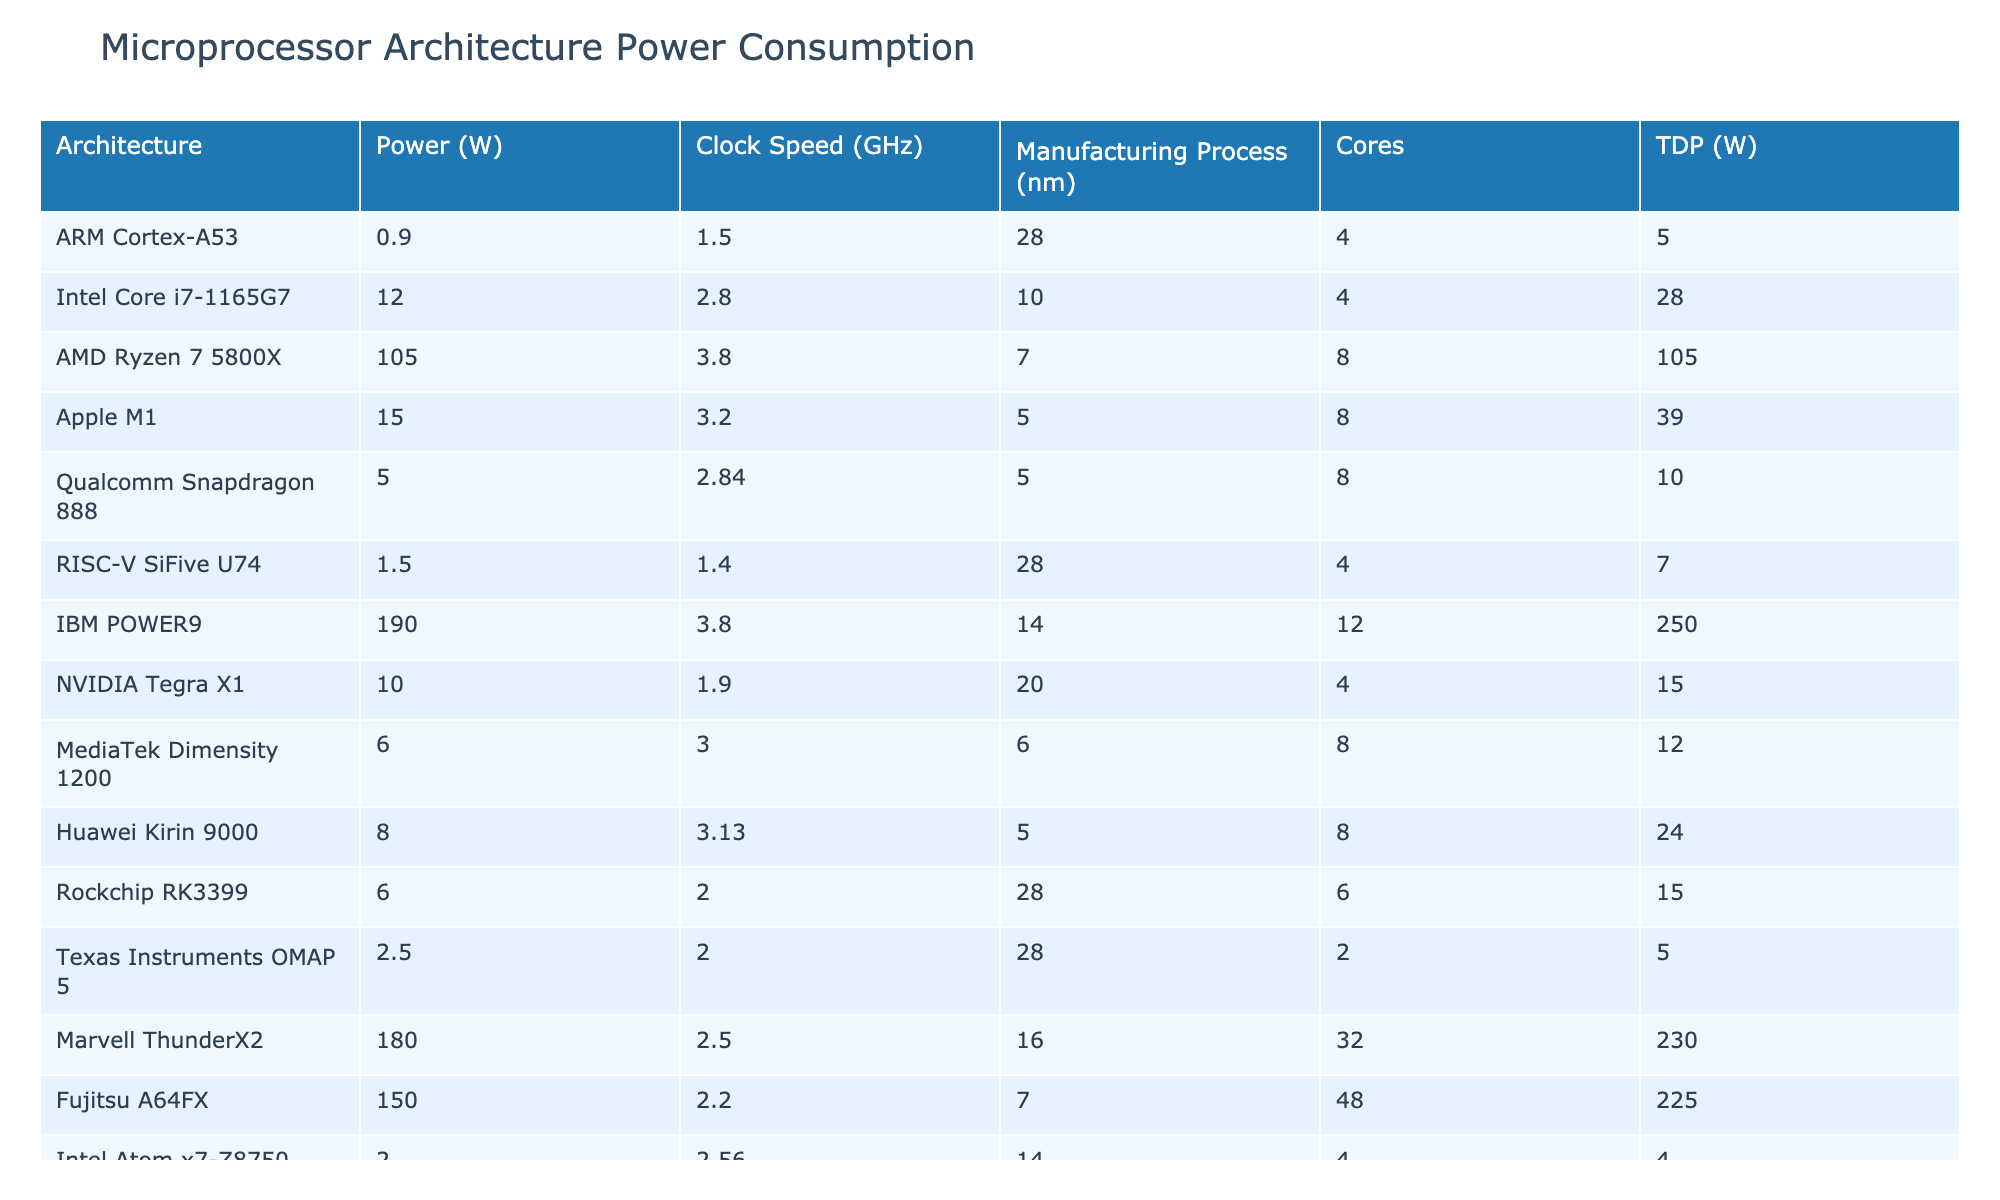What is the power consumption of the Intel Core i7-1165G7? From the table, we can locate the row for the Intel Core i7-1165G7 and read the corresponding power consumption value directly, which is 12 watts.
Answer: 12 W Which microprocessor architecture has the highest power consumption? By examining the table, the architecture with the highest power consumption is IBM POWER9, with a power consumption of 190 watts.
Answer: IBM POWER9 What is the total power consumption of all microprocessors listed? To find the total power consumption, we sum all the values in the 'Power (W)' column: 0.9 + 12 + 105 + 15 + 5 + 1.5 + 190 + 10 + 6 + 8 + 6 + 2.5 + 180 + 150 + 2 = 573.9 watts.
Answer: 573.9 W What is the average power consumption of the microprocessors using a 10 nm manufacturing process? From the table, there is only one entry with a 10 nm manufacturing process, which is the Intel Core i7-1165G7 with a power consumption of 12 watts. Hence, the average is simply 12 watts.
Answer: 12 W Is there a microprocessor architecture with a power consumption less than 5 watts? Looking at the table, the ARM Cortex-A53 is the only architecture with a power consumption less than 5 watts, consuming 0.9 watts. This confirms that yes, there is a microprocessor architecture under 5 watts.
Answer: Yes Which microprocessor has the most cores among those listed? By checking the 'Cores' column, IBM POWER9 has the highest number of cores, which is 12 cores.
Answer: IBM POWER9 What is the difference in power consumption between the highest and lowest power consuming microprocessors? The highest power consuming microprocessor is IBM POWER9 at 190 watts and the lowest is ARM Cortex-A53 at 0.9 watts. The difference is 190 - 0.9 = 189.1 watts.
Answer: 189.1 W List the architectures that consume more than 100 watts of power. By examining the 'Power (W)' column, the architectures that exceed 100 watts are AMD Ryzen 7 5800X (105 W), IBM POWER9 (190 W), Marvell ThunderX2 (180 W), and Fujitsu A64FX (150 W).
Answer: AMD Ryzen 7 5800X, IBM POWER9, Marvell ThunderX2, Fujitsu A64FX Is the average power consumption of processors using a 28 nm manufacturing process greater than 15 watts? The processors using a 28 nm process are ARM Cortex-A53, RISC-V SiFive U74, Texas Instruments OMAP 5, and Rockchip RK3399. Their power consumptions are 0.9, 1.5, 2.5, and 6 watts respectively. The average is (0.9 + 1.5 + 2.5 + 6)/4 = 2.975 watts, which is not greater than 15 watts.
Answer: No What is the total TDP for all microprocessors noted in the table? To find the total TDP, sum all the values in the 'TDP (W)' column: 5 + 28 + 105 + 39 + 10 + 7 + 250 + 15 + 12 + 24 + 15 + 5 + 230 + 225 + 4 = 710 watts.
Answer: 710 W 